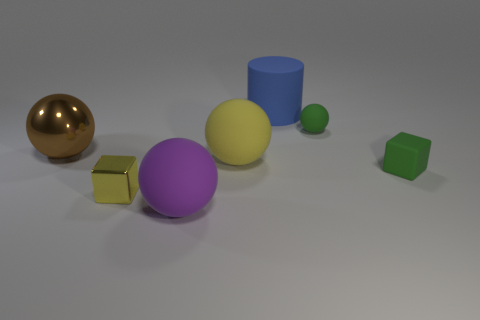There is a big blue rubber thing to the right of the metal object on the right side of the big brown thing; what is its shape?
Offer a terse response. Cylinder. What number of other things are the same shape as the small yellow metal thing?
Provide a succinct answer. 1. Are there any brown metal objects in front of the brown object?
Offer a very short reply. No. What color is the small metallic cube?
Ensure brevity in your answer.  Yellow. There is a matte cylinder; is its color the same as the small block in front of the small green cube?
Offer a very short reply. No. Are there any green metallic balls that have the same size as the blue matte cylinder?
Offer a very short reply. No. What size is the object that is the same color as the matte cube?
Ensure brevity in your answer.  Small. There is a yellow thing that is behind the small yellow object; what material is it?
Give a very brief answer. Rubber. Is the number of big brown metal spheres in front of the yellow matte ball the same as the number of blue matte objects on the right side of the blue object?
Give a very brief answer. Yes. Is the size of the matte cylinder that is on the right side of the large yellow object the same as the rubber sphere behind the big yellow rubber thing?
Give a very brief answer. No. 